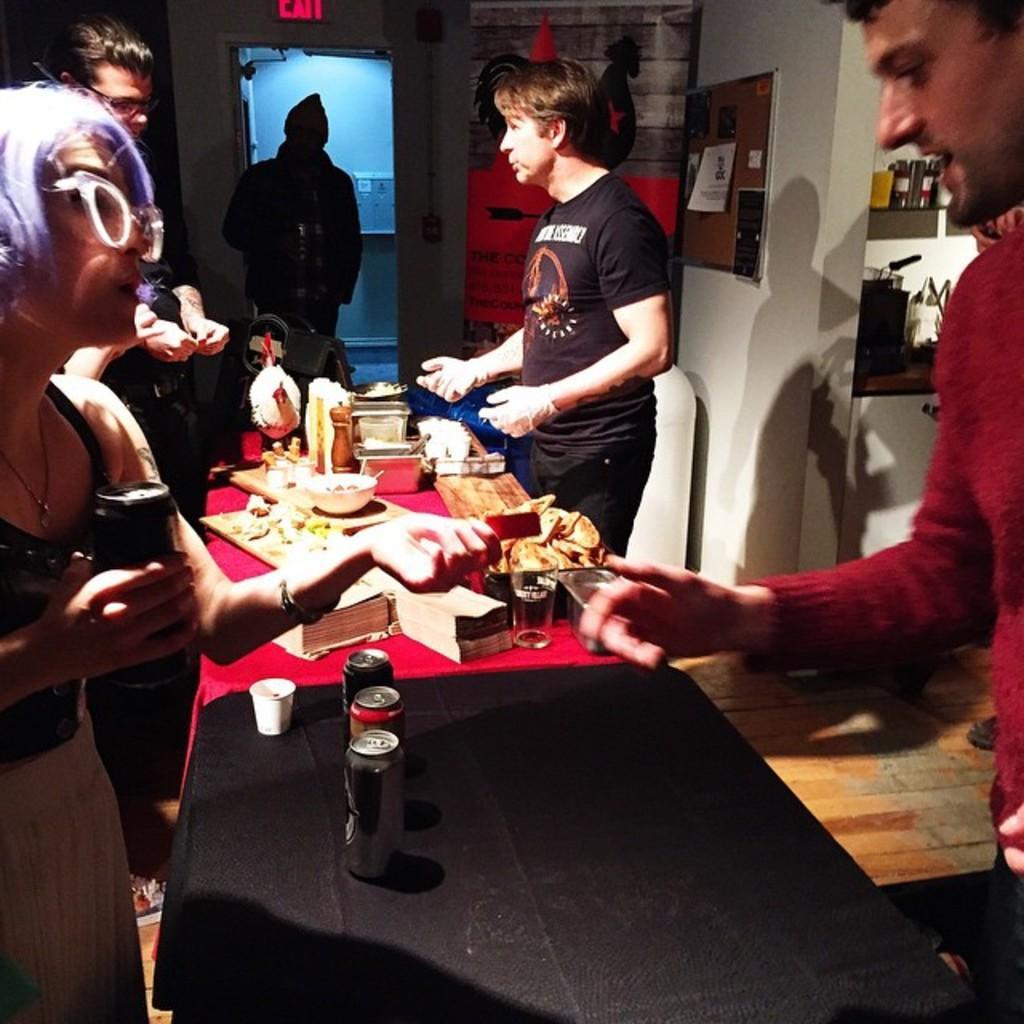Could you give a brief overview of what you see in this image? On the table there is bottle,glass,food,bowl,cup,person are standing near the table. 